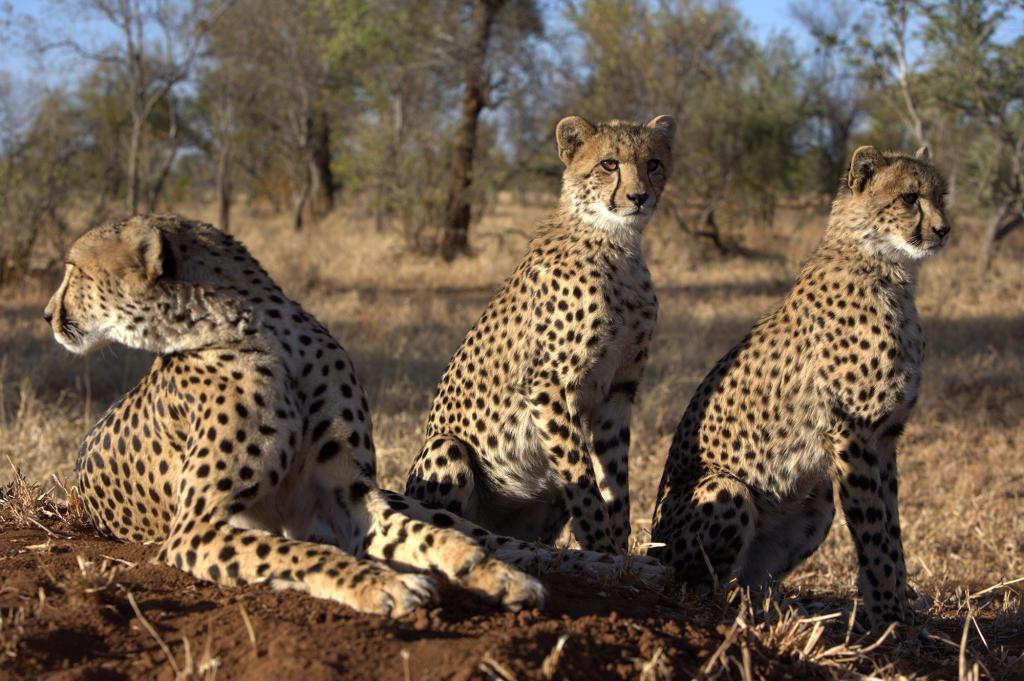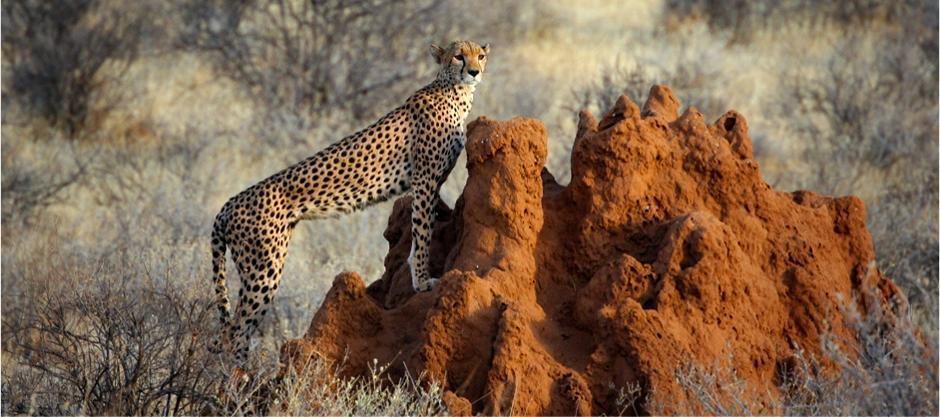The first image is the image on the left, the second image is the image on the right. Examine the images to the left and right. Is the description "There are exactly three cheetahs in the left image." accurate? Answer yes or no. Yes. The first image is the image on the left, the second image is the image on the right. Analyze the images presented: Is the assertion "The left image shows at least one cheetah standing in front of mounded dirt, and the right image contains just one cheetah." valid? Answer yes or no. No. 